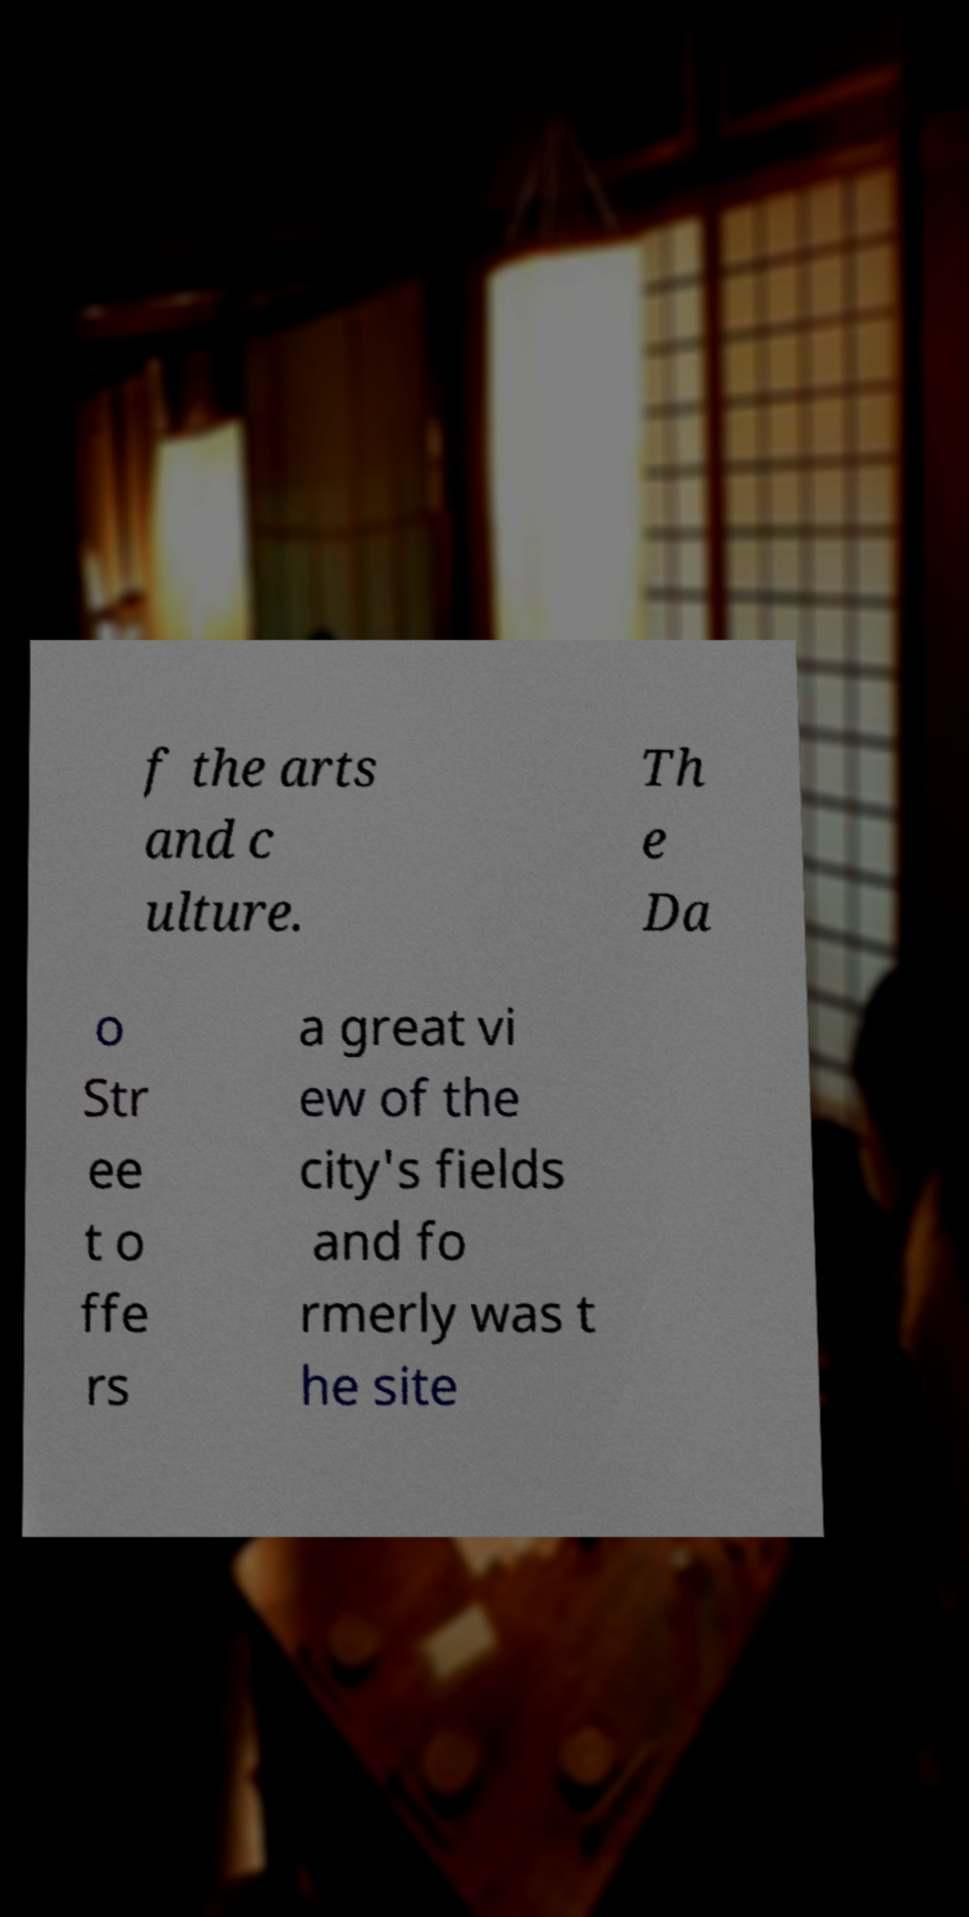Please read and relay the text visible in this image. What does it say? f the arts and c ulture. Th e Da o Str ee t o ffe rs a great vi ew of the city's fields and fo rmerly was t he site 